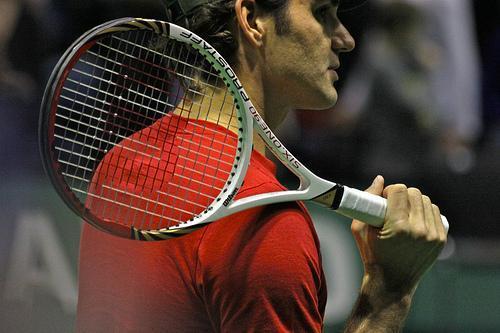How many tennis players are in the photo?
Give a very brief answer. 1. How many people have brown hair?
Give a very brief answer. 1. 